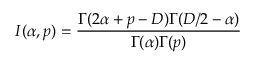Convert formula to latex. <formula><loc_0><loc_0><loc_500><loc_500>I ( \alpha , p ) = \frac { \Gamma ( 2 \alpha + p - D ) \Gamma ( D / 2 - \alpha ) } { \Gamma ( \alpha ) \Gamma ( p ) }</formula> 